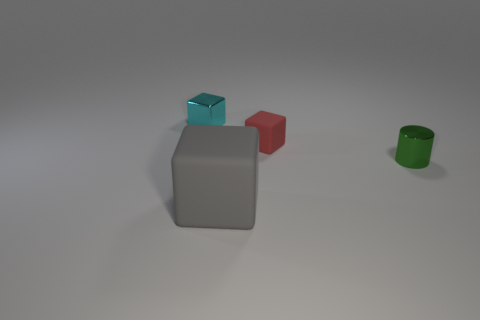Is the number of cyan objects in front of the small metallic block greater than the number of rubber cubes?
Ensure brevity in your answer.  No. Does the tiny shiny object left of the tiny red rubber block have the same color as the large block?
Offer a very short reply. No. Are there any other things that have the same color as the large matte cube?
Your answer should be very brief. No. There is a metal object right of the tiny cube behind the red thing to the right of the large gray matte block; what color is it?
Your answer should be compact. Green. Do the shiny cylinder and the red matte object have the same size?
Make the answer very short. Yes. What number of blocks have the same size as the red thing?
Your response must be concise. 1. Is the small object that is on the left side of the big gray matte cube made of the same material as the block in front of the green object?
Give a very brief answer. No. Is there anything else that is the same shape as the big gray thing?
Make the answer very short. Yes. The big block is what color?
Your response must be concise. Gray. How many cyan metal things are the same shape as the big gray rubber thing?
Offer a terse response. 1. 